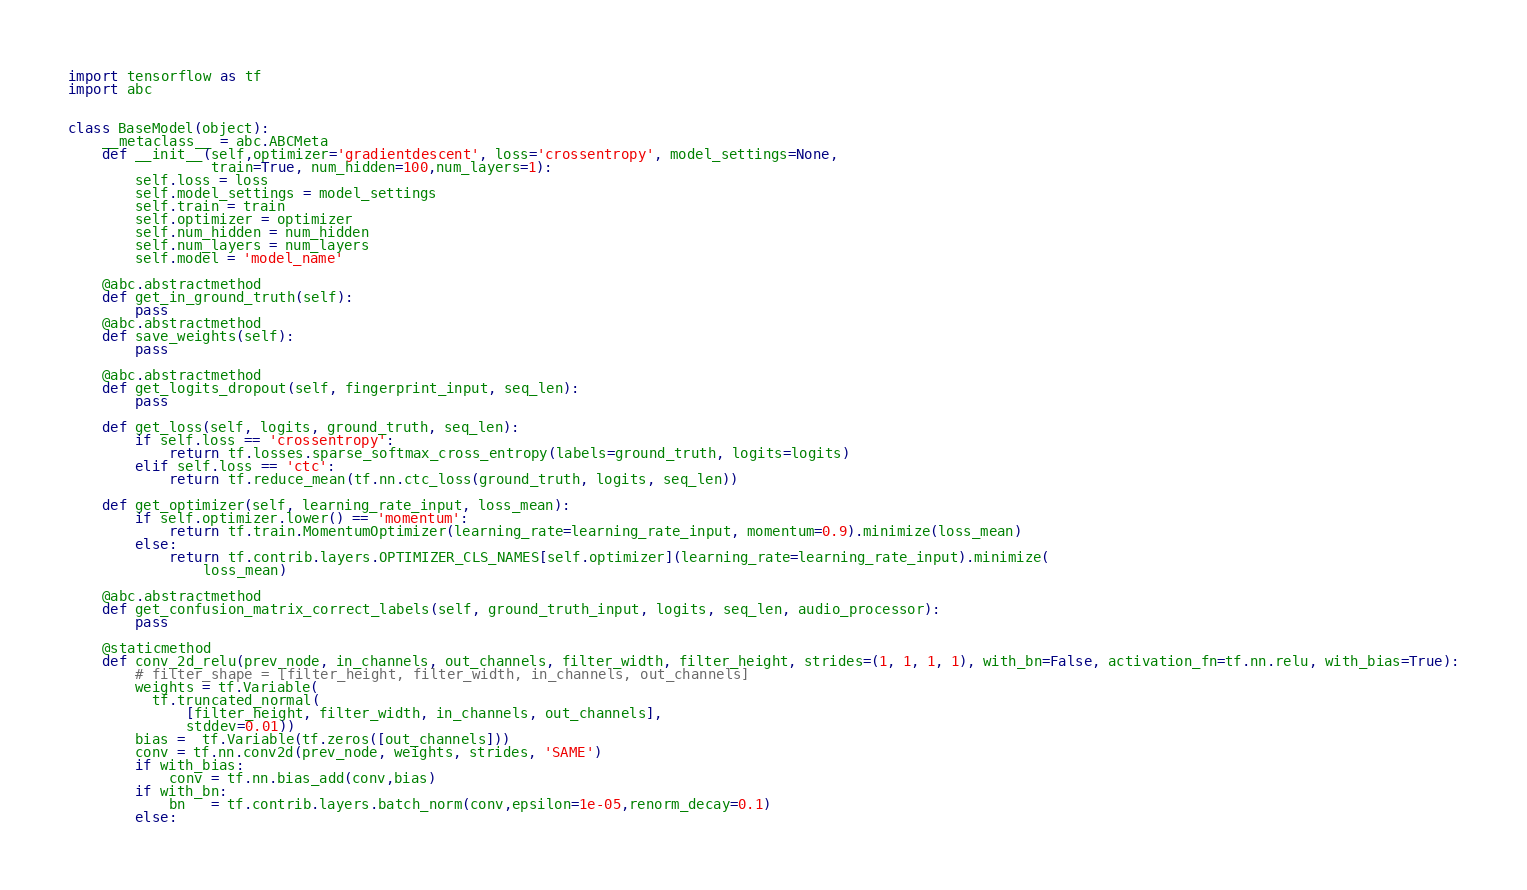Convert code to text. <code><loc_0><loc_0><loc_500><loc_500><_Python_>import tensorflow as tf
import abc


class BaseModel(object):
    __metaclass__ = abc.ABCMeta
    def __init__(self,optimizer='gradientdescent', loss='crossentropy', model_settings=None,
                 train=True, num_hidden=100,num_layers=1):
        self.loss = loss
        self.model_settings = model_settings
        self.train = train
        self.optimizer = optimizer
        self.num_hidden = num_hidden
        self.num_layers = num_layers
        self.model = 'model_name'

    @abc.abstractmethod
    def get_in_ground_truth(self):
        pass
    @abc.abstractmethod
    def save_weights(self):
        pass

    @abc.abstractmethod
    def get_logits_dropout(self, fingerprint_input, seq_len):
        pass

    def get_loss(self, logits, ground_truth, seq_len):
        if self.loss == 'crossentropy':
            return tf.losses.sparse_softmax_cross_entropy(labels=ground_truth, logits=logits)
        elif self.loss == 'ctc':
            return tf.reduce_mean(tf.nn.ctc_loss(ground_truth, logits, seq_len))

    def get_optimizer(self, learning_rate_input, loss_mean):
        if self.optimizer.lower() == 'momentum':
            return tf.train.MomentumOptimizer(learning_rate=learning_rate_input, momentum=0.9).minimize(loss_mean)
        else:
            return tf.contrib.layers.OPTIMIZER_CLS_NAMES[self.optimizer](learning_rate=learning_rate_input).minimize(
                loss_mean)

    @abc.abstractmethod
    def get_confusion_matrix_correct_labels(self, ground_truth_input, logits, seq_len, audio_processor):
        pass

    @staticmethod
    def conv_2d_relu(prev_node, in_channels, out_channels, filter_width, filter_height, strides=(1, 1, 1, 1), with_bn=False, activation_fn=tf.nn.relu, with_bias=True):
        # filter_shape = [filter_height, filter_width, in_channels, out_channels]
        weights = tf.Variable(
          tf.truncated_normal(
              [filter_height, filter_width, in_channels, out_channels],
              stddev=0.01))
        bias =  tf.Variable(tf.zeros([out_channels]))
        conv = tf.nn.conv2d(prev_node, weights, strides, 'SAME')
        if with_bias:
            conv = tf.nn.bias_add(conv,bias)
        if with_bn:
            bn   = tf.contrib.layers.batch_norm(conv,epsilon=1e-05,renorm_decay=0.1)
        else:</code> 